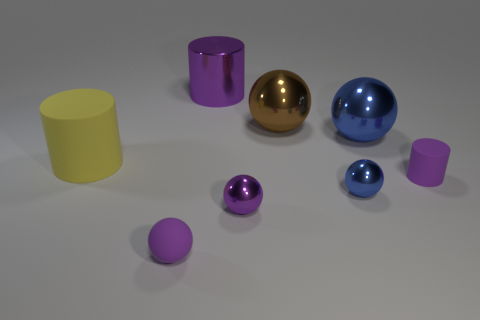How many objects are there and can you describe their shapes and colors? In the image, there are six objects. Starting from the left, there's a yellow cylinder, a large purple cylinder, a small purple sphere, a large gold sphere, a large blue sphere, and a small blue cylinder. Each object has a glossy, metallic finish, reflecting light on their smooth surfaces. 